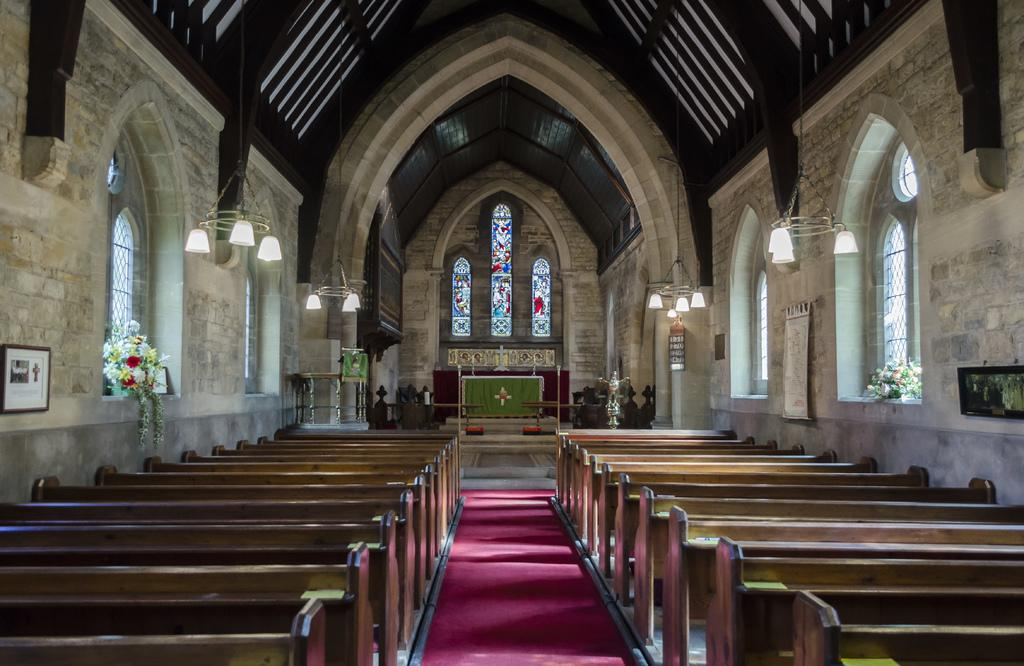What type of building is shown in the image? The image is an inside view of a church. What decorative elements can be seen in the image? There are flowers and lights visible in the image. What type of seating is available in the church? There are benches in the image. What is attached to the wall in the image? There is a wall with objects attached to it in the image. What is the purpose of the fireman in the image? There is no fireman present in the image; it is an inside view of a church. 